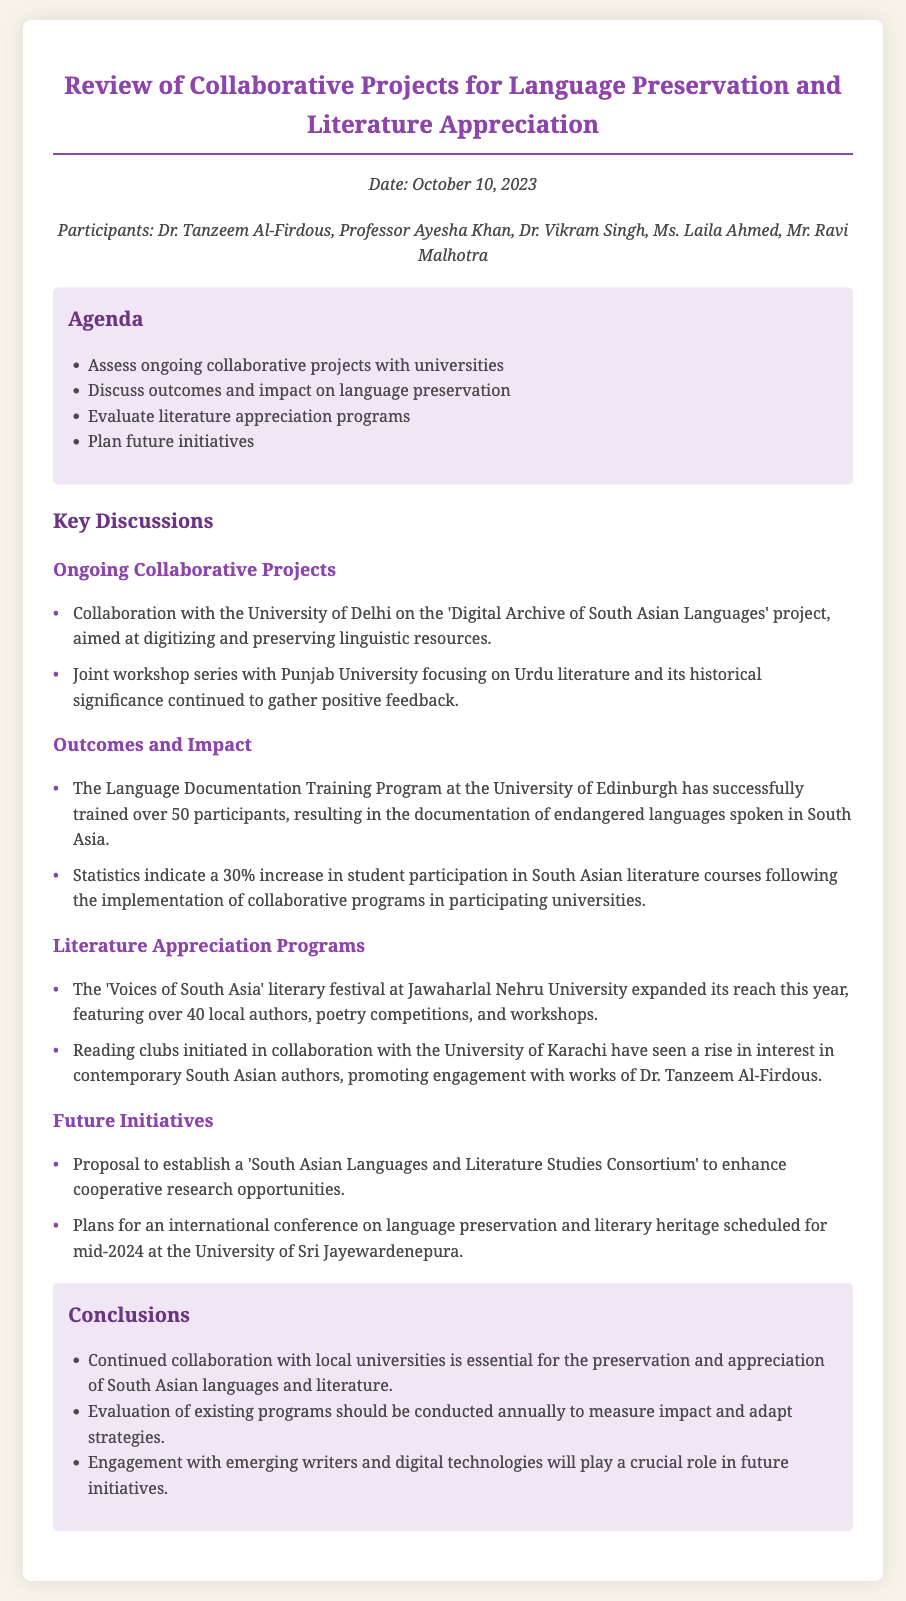What is the date of the meeting? The date of the meeting is mentioned at the top of the document.
Answer: October 10, 2023 Who are the participants in the meeting? The participants list is provided under the date section, listing all individuals present.
Answer: Dr. Tanzeem Al-Firdous, Professor Ayesha Khan, Dr. Vikram Singh, Ms. Laila Ahmed, Mr. Ravi Malhotra What is the main goal of the 'Digital Archive of South Asian Languages' project? This project is highlighted as aimed at digitizing and preserving linguistic resources.
Answer: Digitizing and preserving linguistic resources How many participants were trained in the Language Documentation Training Program? The number of participants trained is stated explicitly in the discussions section.
Answer: Over 50 participants What event expanded its reach this year with over 40 local authors? The document describes a specific event that had significant participation from local authors.
Answer: Voices of South Asia literary festival What proposal was made for future initiatives? A specific proposal for future collaboration is presented in the discussions section, focusing on cooperative research.
Answer: South Asian Languages and Literature Studies Consortium What crucial role will engagement with emerging writers play? The document mentions the importance of a particular engagement in the context of future initiatives.
Answer: Future initiatives How often should the evaluation of existing programs be conducted? This information is provided in the conclusions section regarding program evaluations.
Answer: Annually 